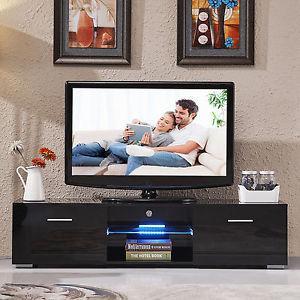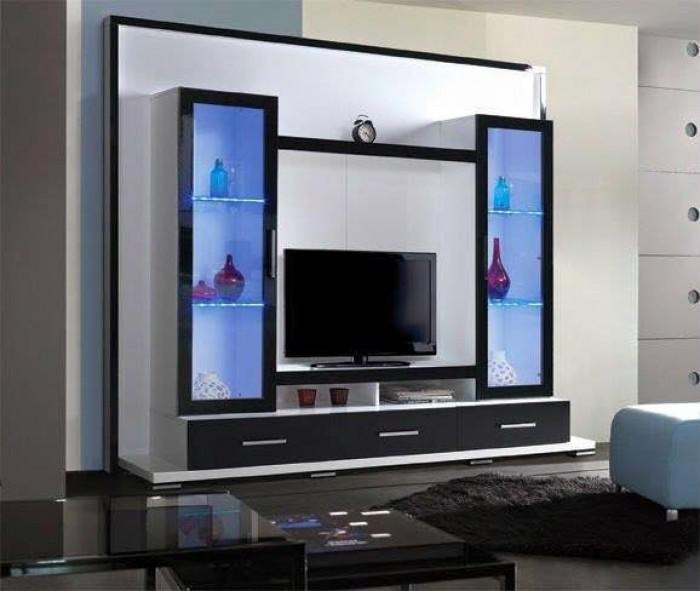The first image is the image on the left, the second image is the image on the right. Evaluate the accuracy of this statement regarding the images: "There are two people on the television on the left.". Is it true? Answer yes or no. Yes. 